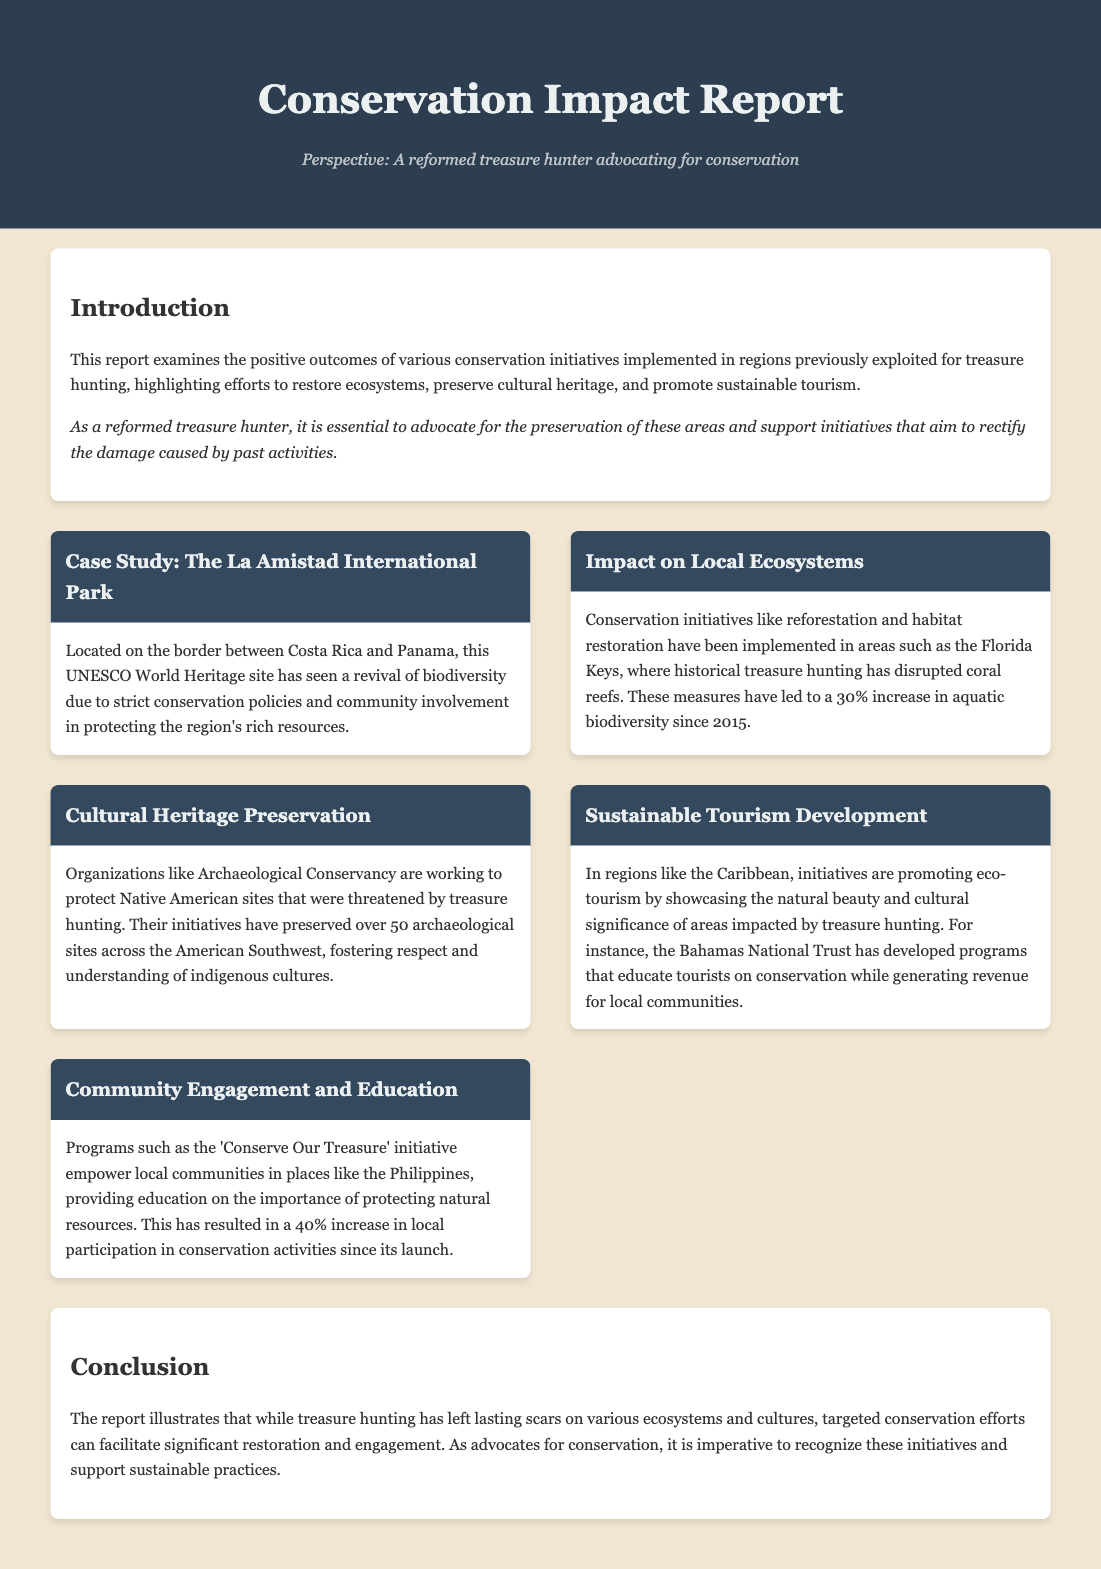what is the title of the report? The title of the report is stated at the top of the document as "Conservation Impact Report".
Answer: Conservation Impact Report what is the UNESCO site mentioned? The document mentions "La Amistad International Park" as a UNESCO World Heritage site.
Answer: La Amistad International Park how much has aquatic biodiversity increased since 2015? The report states that there has been a 30% increase in aquatic biodiversity since 2015.
Answer: 30% which organization is working to protect Native American sites? The document identifies "Archaeological Conservancy" as the organization working to protect these sites.
Answer: Archaeological Conservancy what percentage increase in local participation did the 'Conserve Our Treasure' initiative achieve? The report states that there has been a 40% increase in local participation in conservation activities.
Answer: 40% what type of tourism is being promoted in the Caribbean? The document mentions that "eco-tourism" is being promoted in the Caribbean.
Answer: eco-tourism what has been a focus of community engagement programs? The report highlights the importance of "education on the importance of protecting natural resources".
Answer: education on the importance of protecting natural resources how many archaeological sites have been preserved? The document states that over 50 archaeological sites have been preserved.
Answer: 50 